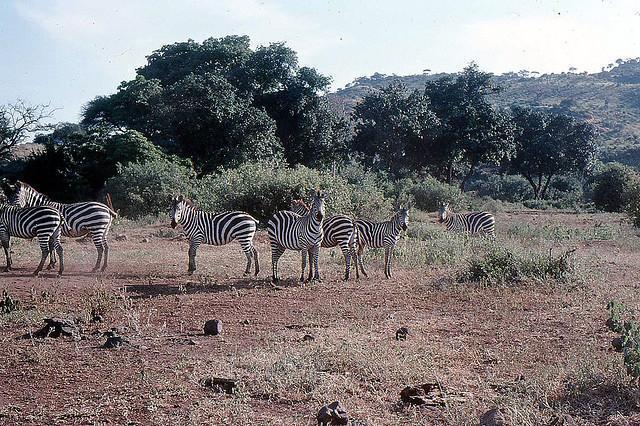How many zebras are visible?
Give a very brief answer. 4. How many elephants are in this picture?
Give a very brief answer. 0. 